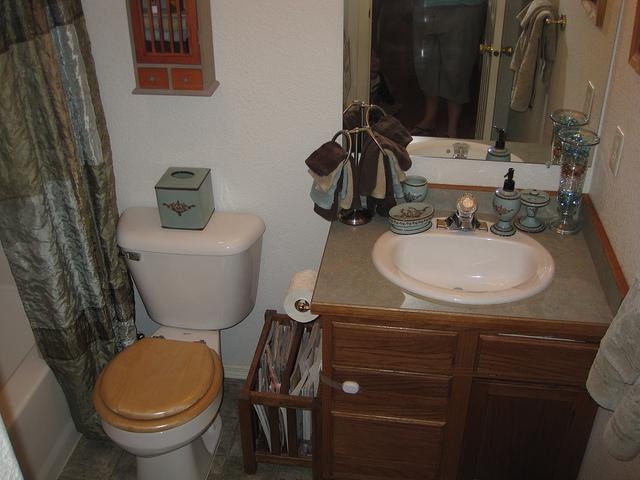What color is the tissue box on the top of the toilet bowl?

Choices:
A) red
B) purple
C) blue
D) yellow blue 